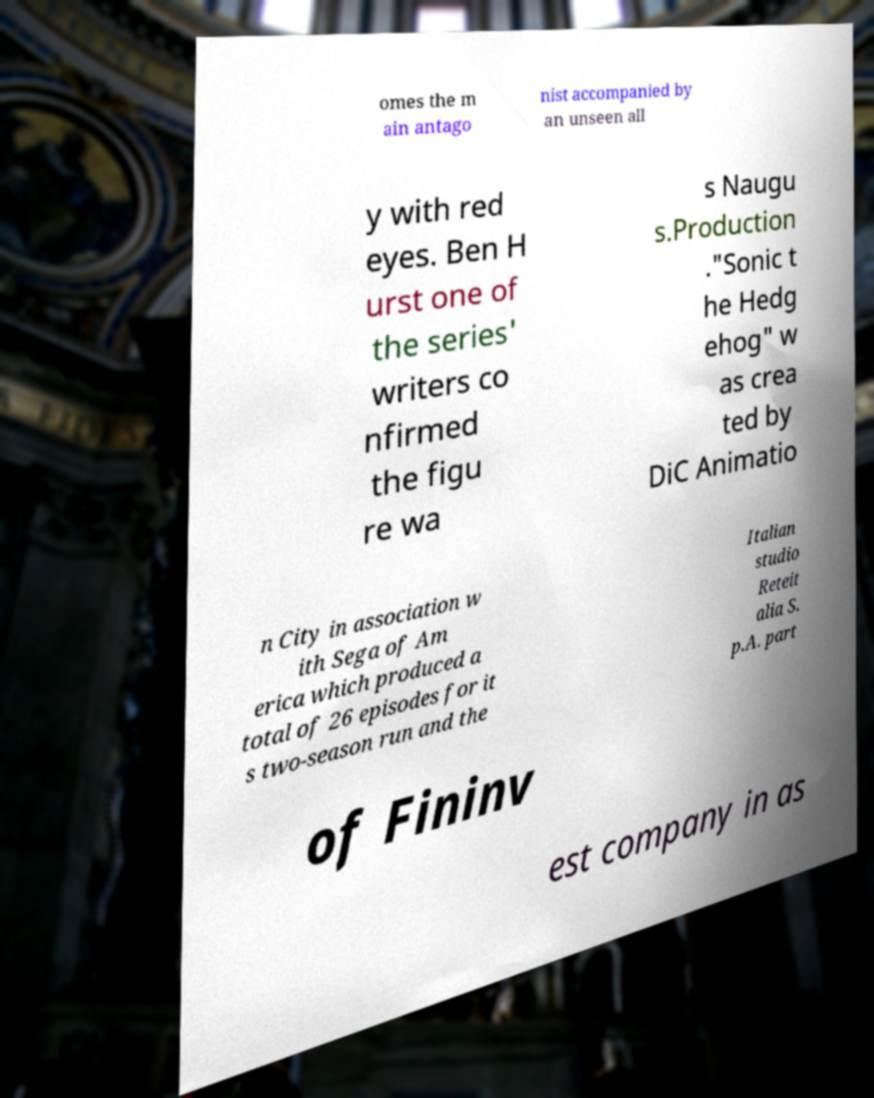Could you assist in decoding the text presented in this image and type it out clearly? omes the m ain antago nist accompanied by an unseen all y with red eyes. Ben H urst one of the series' writers co nfirmed the figu re wa s Naugu s.Production ."Sonic t he Hedg ehog" w as crea ted by DiC Animatio n City in association w ith Sega of Am erica which produced a total of 26 episodes for it s two-season run and the Italian studio Reteit alia S. p.A. part of Fininv est company in as 